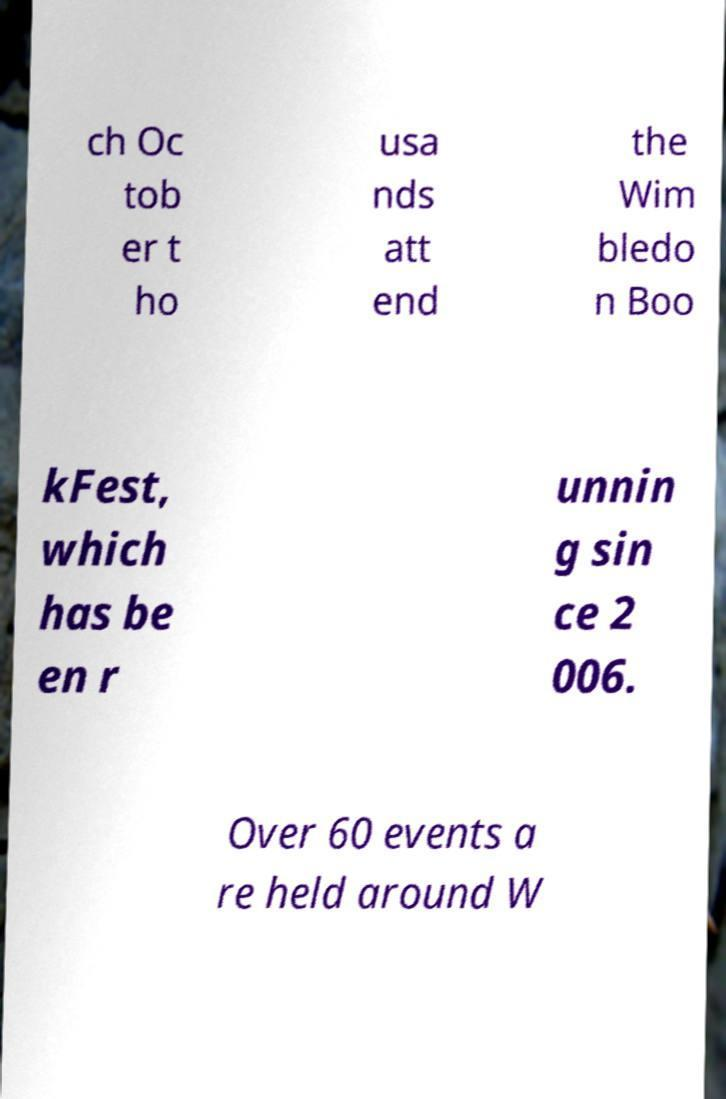Please identify and transcribe the text found in this image. ch Oc tob er t ho usa nds att end the Wim bledo n Boo kFest, which has be en r unnin g sin ce 2 006. Over 60 events a re held around W 